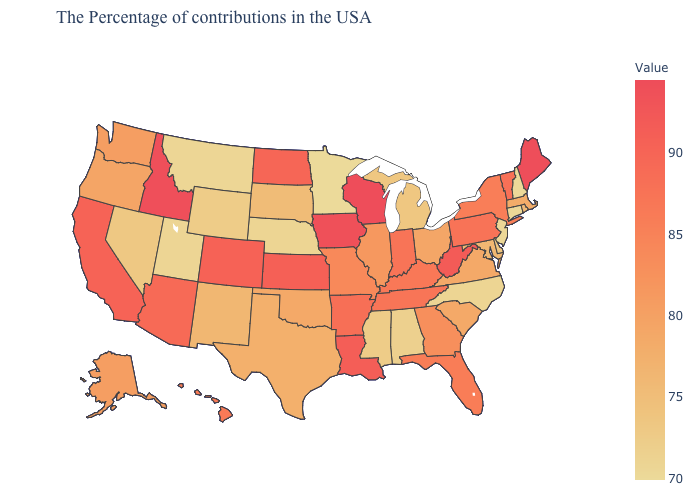Does Massachusetts have a lower value than Delaware?
Concise answer only. No. Among the states that border Delaware , does New Jersey have the lowest value?
Give a very brief answer. Yes. Does Montana have a higher value than Florida?
Concise answer only. No. 